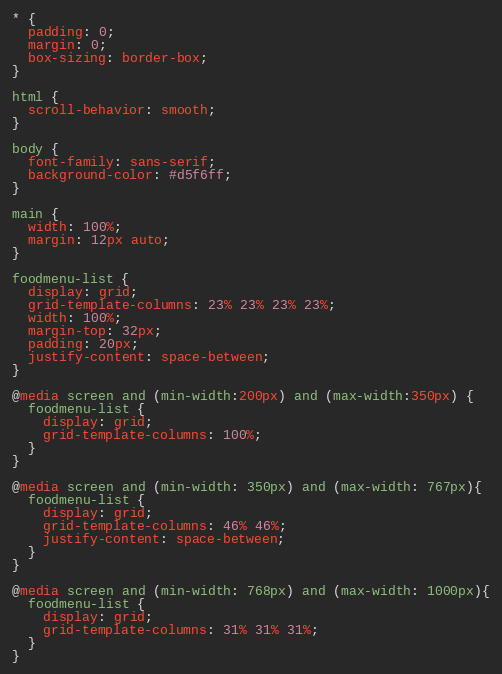Convert code to text. <code><loc_0><loc_0><loc_500><loc_500><_CSS_>* {
  padding: 0;
  margin: 0;
  box-sizing: border-box;
}

html {
  scroll-behavior: smooth;
}

body {
  font-family: sans-serif;
  background-color: #d5f6ff;
}

main {
  width: 100%;
  margin: 12px auto;
}

foodmenu-list {
  display: grid;
  grid-template-columns: 23% 23% 23% 23%;
  width: 100%;
  margin-top: 32px;
  padding: 20px;
  justify-content: space-between;
}

@media screen and (min-width:200px) and (max-width:350px) {
  foodmenu-list {
    display: grid;
    grid-template-columns: 100%;
  }
}

@media screen and (min-width: 350px) and (max-width: 767px){
  foodmenu-list {
    display: grid;
    grid-template-columns: 46% 46%;
    justify-content: space-between;
  }
}

@media screen and (min-width: 768px) and (max-width: 1000px){
  foodmenu-list {
    display: grid;
    grid-template-columns: 31% 31% 31%;
  }
}
</code> 